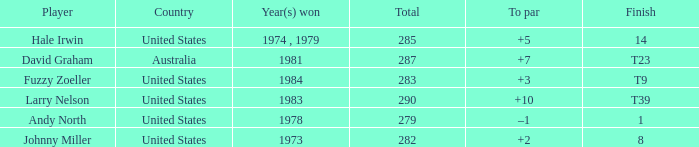Would you be able to parse every entry in this table? {'header': ['Player', 'Country', 'Year(s) won', 'Total', 'To par', 'Finish'], 'rows': [['Hale Irwin', 'United States', '1974 , 1979', '285', '+5', '14'], ['David Graham', 'Australia', '1981', '287', '+7', 'T23'], ['Fuzzy Zoeller', 'United States', '1984', '283', '+3', 'T9'], ['Larry Nelson', 'United States', '1983', '290', '+10', 'T39'], ['Andy North', 'United States', '1978', '279', '–1', '1'], ['Johnny Miller', 'United States', '1973', '282', '+2', '8']]} Which player finished at +10? Larry Nelson. 